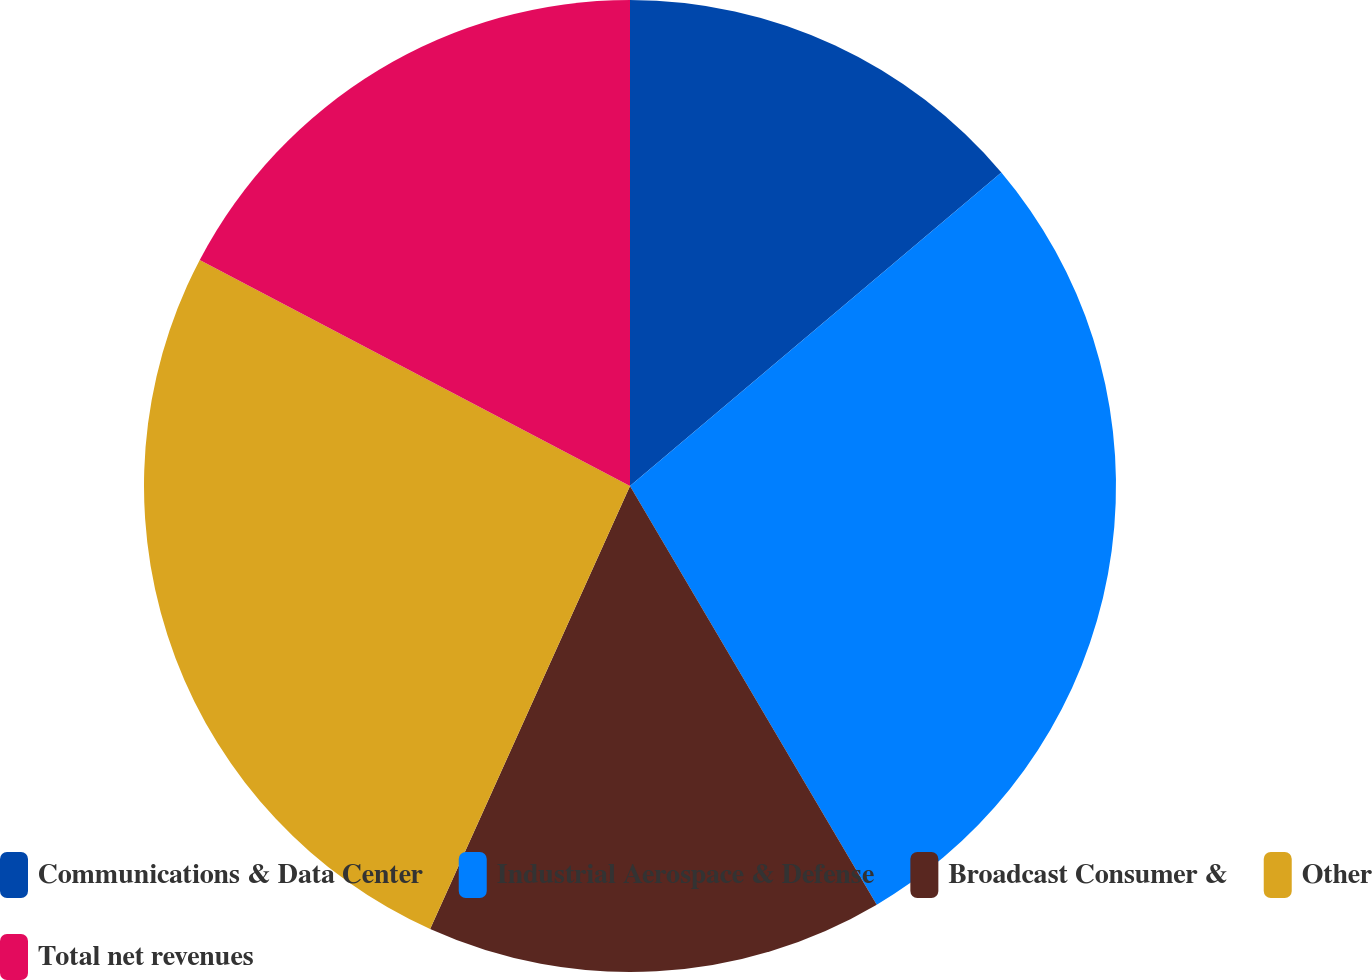Convert chart to OTSL. <chart><loc_0><loc_0><loc_500><loc_500><pie_chart><fcel>Communications & Data Center<fcel>Industrial Aerospace & Defense<fcel>Broadcast Consumer &<fcel>Other<fcel>Total net revenues<nl><fcel>13.84%<fcel>27.68%<fcel>15.22%<fcel>25.95%<fcel>17.3%<nl></chart> 